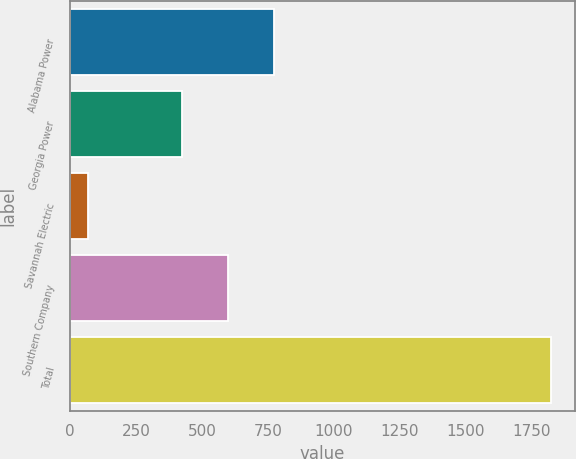Convert chart. <chart><loc_0><loc_0><loc_500><loc_500><bar_chart><fcel>Alabama Power<fcel>Georgia Power<fcel>Savannah Electric<fcel>Southern Company<fcel>Total<nl><fcel>773.8<fcel>423<fcel>70<fcel>598.4<fcel>1824<nl></chart> 